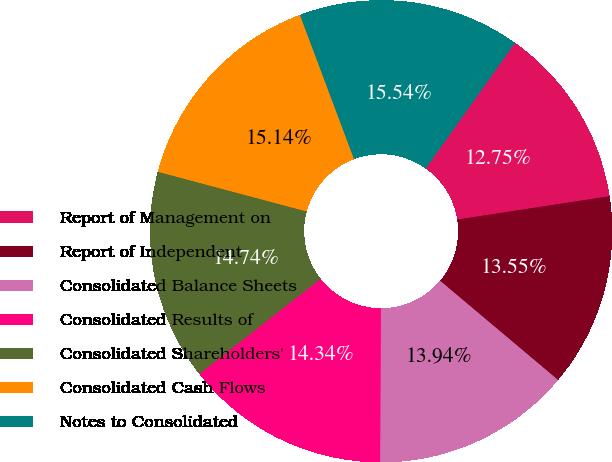Convert chart to OTSL. <chart><loc_0><loc_0><loc_500><loc_500><pie_chart><fcel>Report of Management on<fcel>Report of Independent<fcel>Consolidated Balance Sheets<fcel>Consolidated Results of<fcel>Consolidated Shareholders'<fcel>Consolidated Cash Flows<fcel>Notes to Consolidated<nl><fcel>12.75%<fcel>13.55%<fcel>13.94%<fcel>14.34%<fcel>14.74%<fcel>15.14%<fcel>15.54%<nl></chart> 